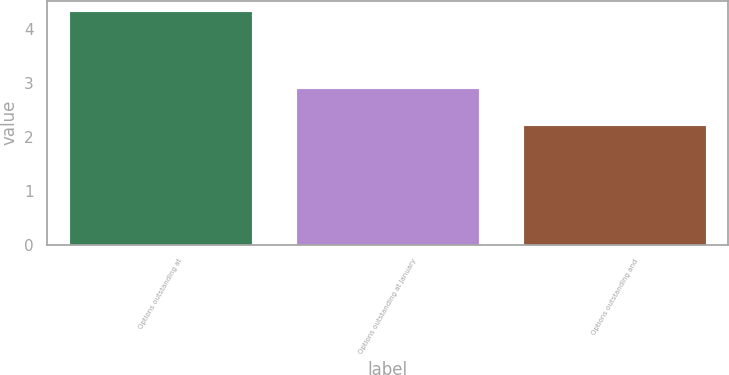<chart> <loc_0><loc_0><loc_500><loc_500><bar_chart><fcel>Options outstanding at<fcel>Options outstanding at January<fcel>Options outstanding and<nl><fcel>4.31<fcel>2.88<fcel>2.2<nl></chart> 